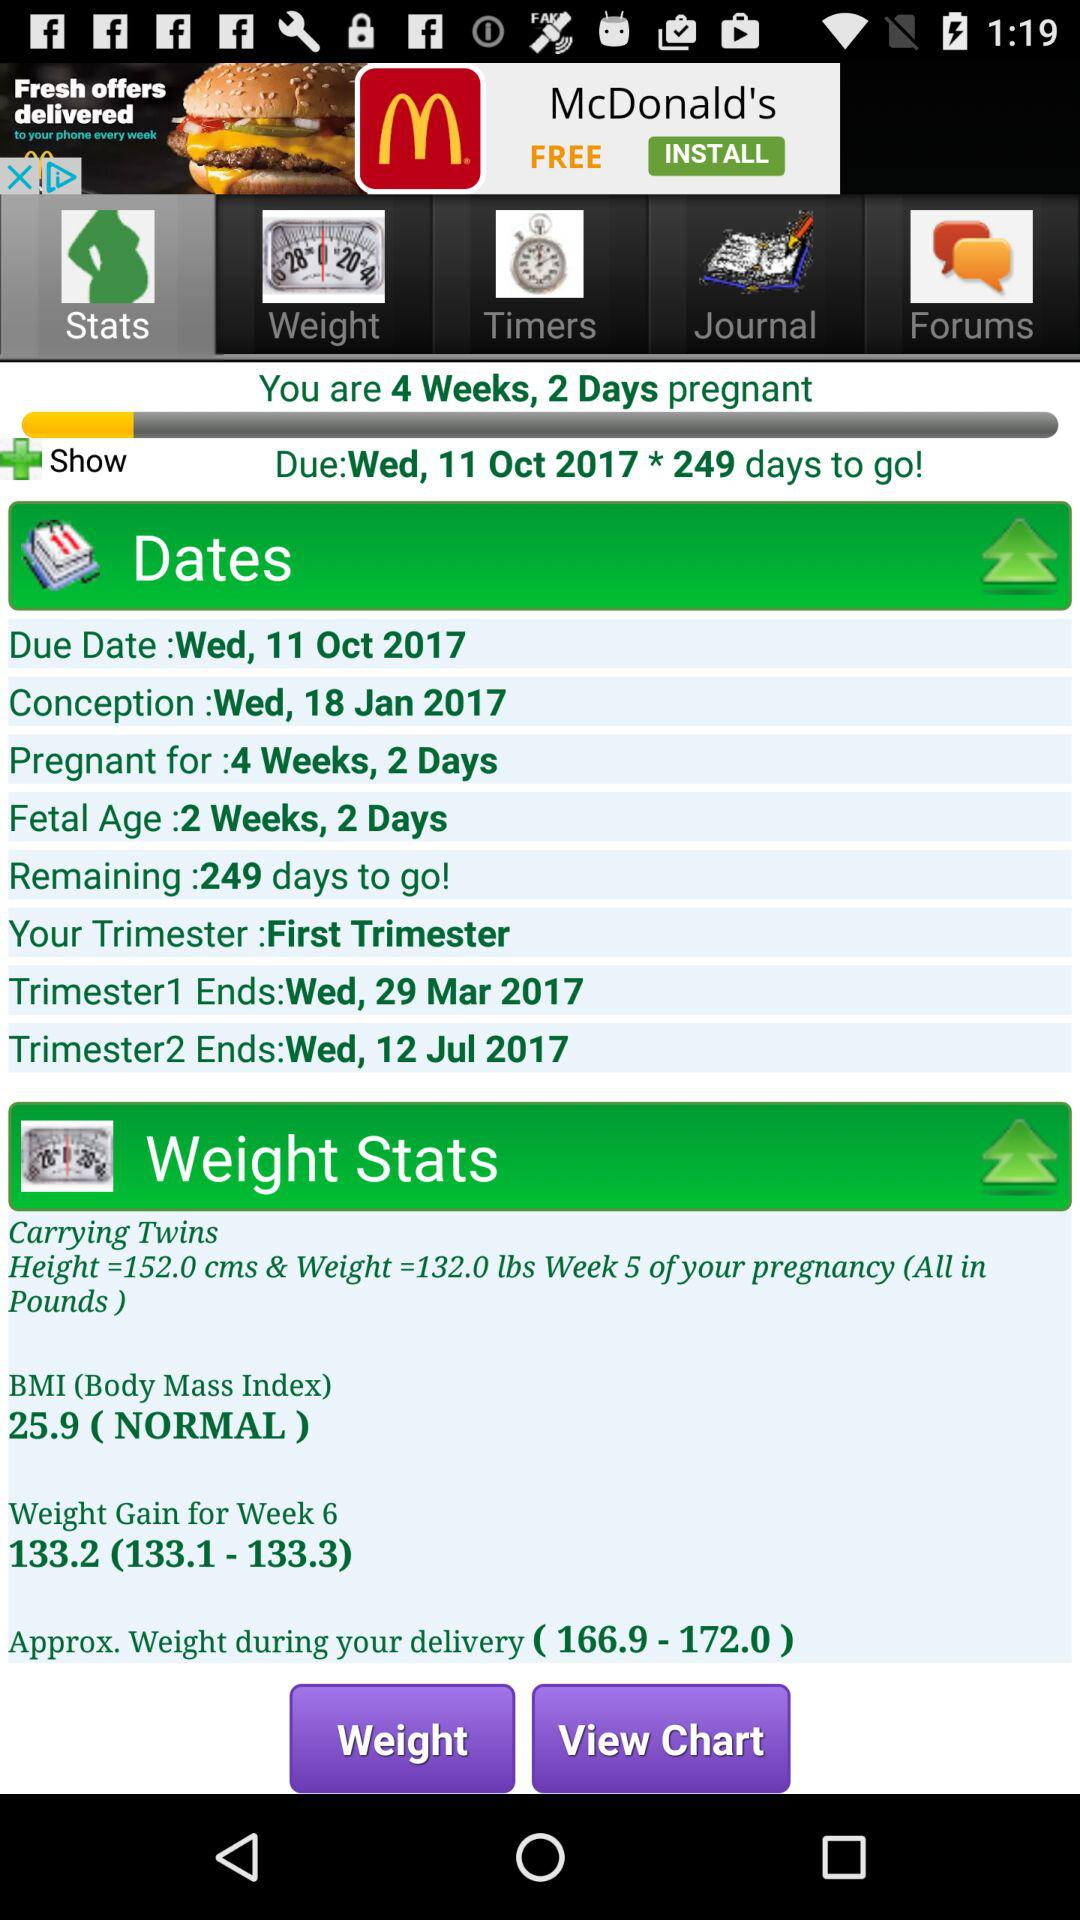What is the "Fetal Age"? The "Fetal Age" is 2 weeks and 2 days. 